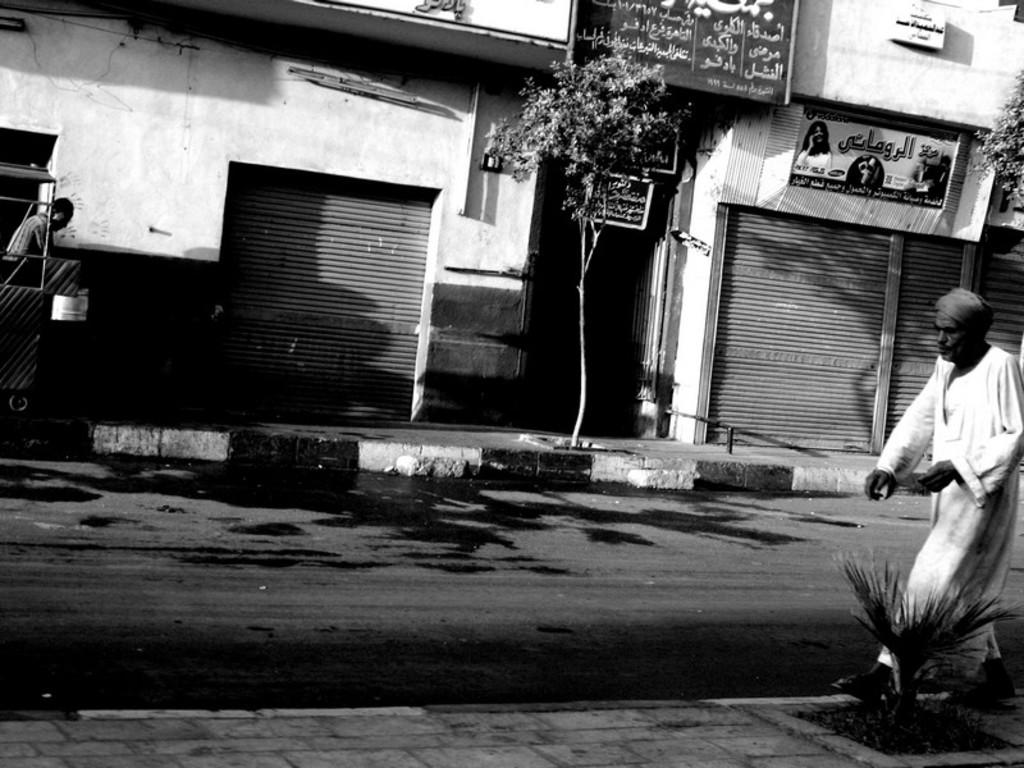What is the color scheme of the image? The image is black and white. How many people are in the image? There are two persons standing in the image. What can be seen in the background of the image? There is a road, shops, name boards, shutters, and trees in the image. What advice does the minister give to the mother in the image? There is no minister or mother present in the image, so no such interaction can be observed. 